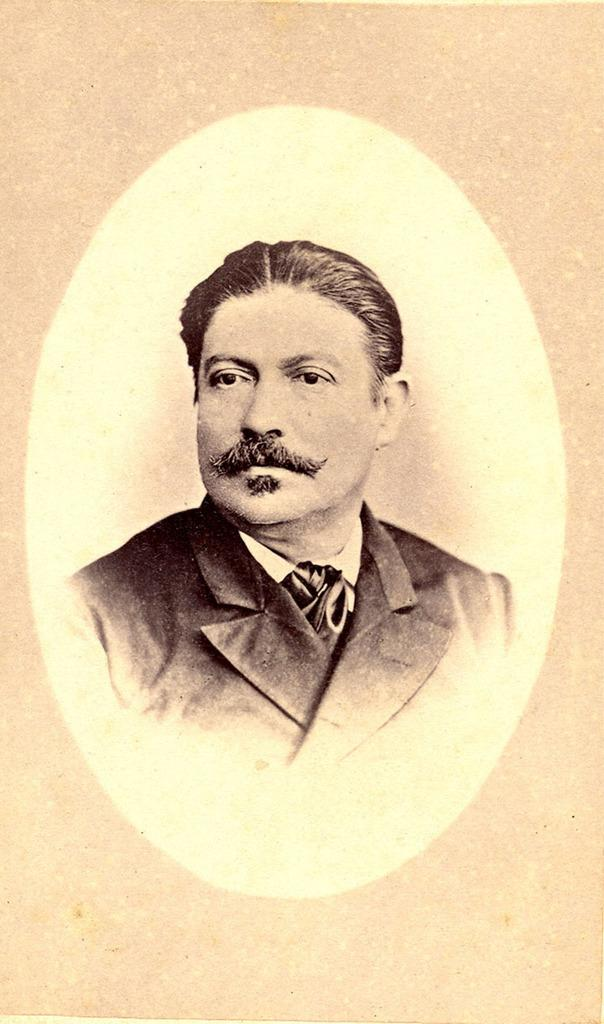What type of person is present in the image? There is a gentleman in the image. What type of plastic item can be seen around the gentleman's neck in the image? There is no plastic item visible around the gentleman's neck in the image. What type of locket is the gentleman holding in the image? There is no locket present in the image. 